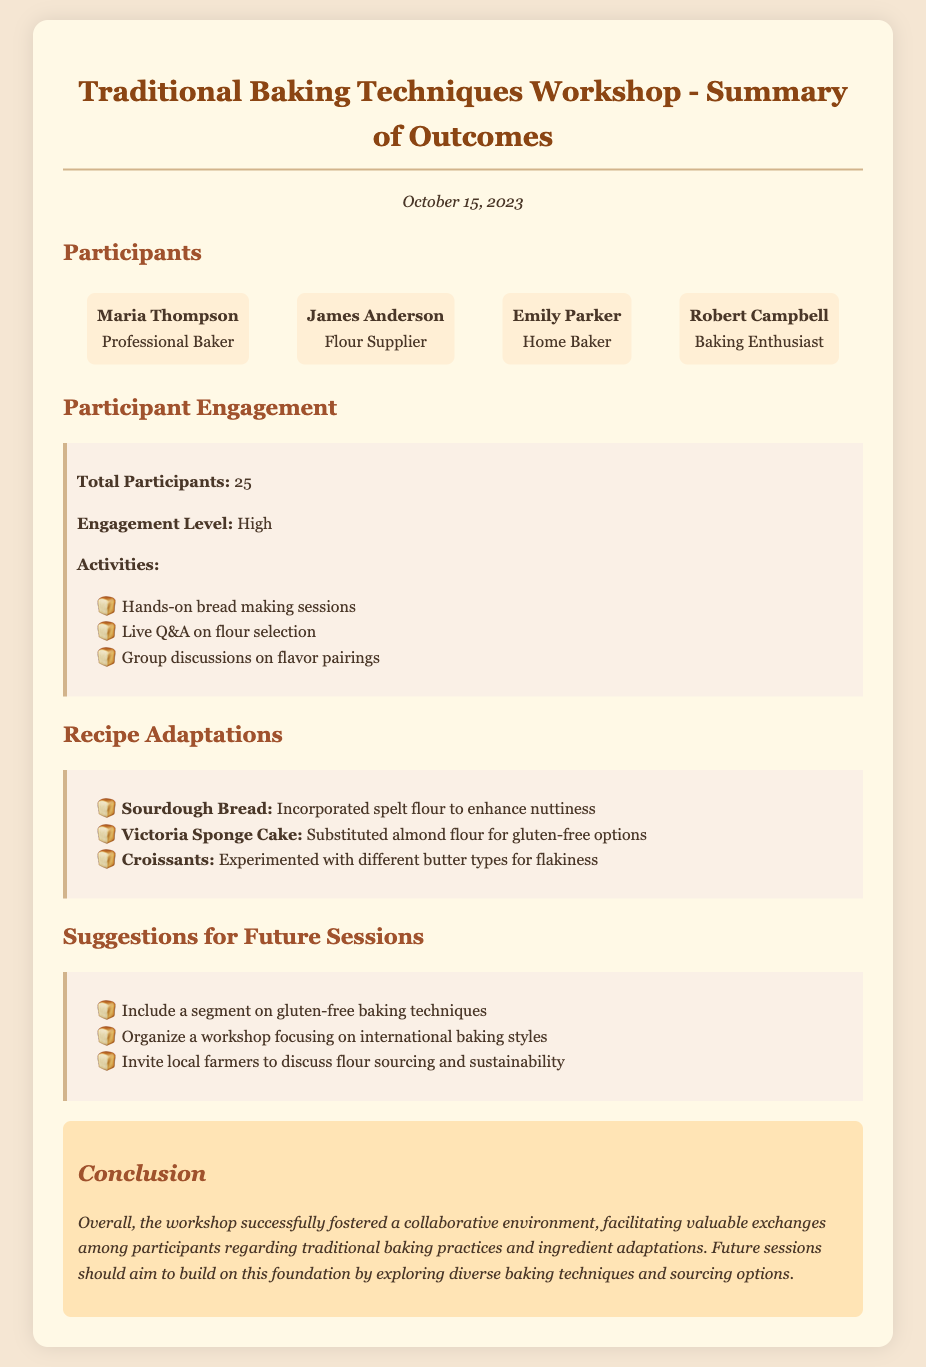What is the date of the workshop? The date of the workshop is mentioned in the document at the beginning as October 15, 2023.
Answer: October 15, 2023 Who is the flour supplier? The flour supplier is listed as James Anderson in the participants section of the document.
Answer: James Anderson What was the engagement level during the workshop? The level of participant engagement is described as high in the participant engagement section.
Answer: High How many participants were there in total? The document states that the total number of participants was 25.
Answer: 25 What was one adaptation made to the sourdough bread recipe? The adaptation mentioned for sourdough bread is the incorporation of spelt flour to enhance nuttiness.
Answer: Incorporated spelt flour What kind of workshop is suggested for the future? A workshop focusing on gluten-free baking techniques is suggested for future sessions.
Answer: Gluten-free baking techniques What are two activities included in the workshop? The document lists hands-on bread making sessions and a live Q&A on flour selection as part of the activities.
Answer: Hands-on bread making sessions and live Q&A Who is mentioned as a baking enthusiast in the participants? Robert Campbell is mentioned as a baking enthusiast in the participants section of the document.
Answer: Robert Campbell What is the main conclusion drawn from the workshop summary? The conclusion drawn is that the workshop successfully fostered a collaborative environment for valuable exchanges among participants.
Answer: Successfully fostered a collaborative environment 